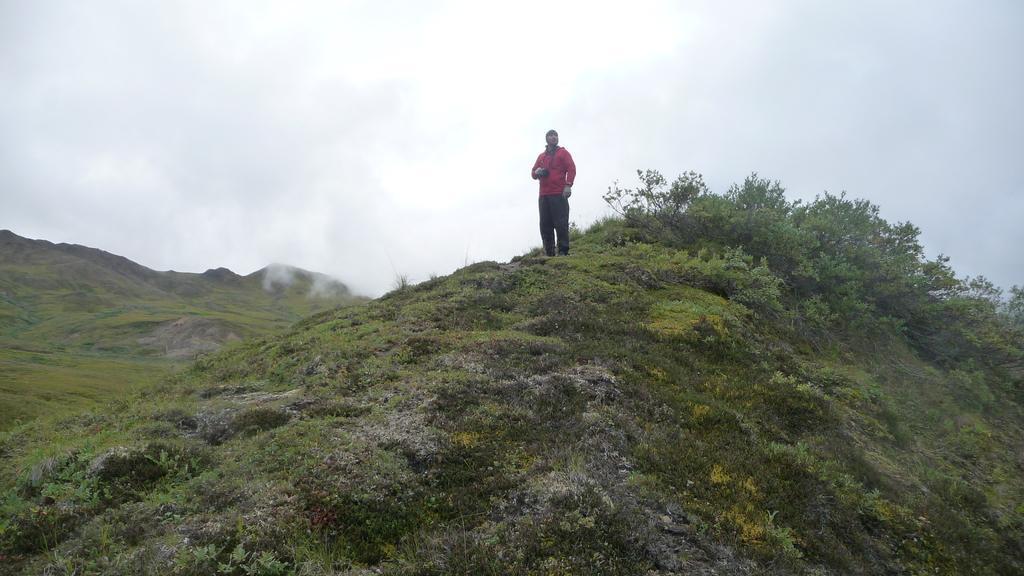Could you give a brief overview of what you see in this image? In this picture we can see a man in the red jacket is standing on the path and behind the man there are plants, fog, hills and a sky. 